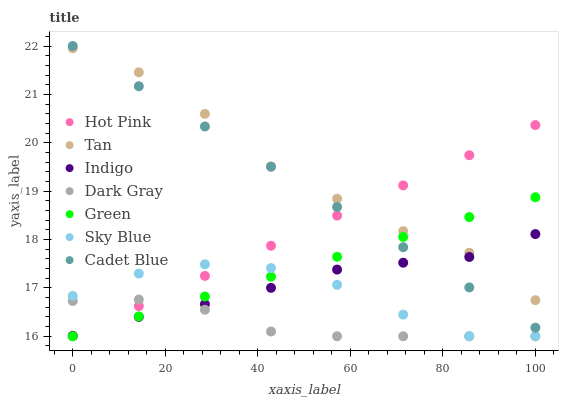Does Dark Gray have the minimum area under the curve?
Answer yes or no. Yes. Does Tan have the maximum area under the curve?
Answer yes or no. Yes. Does Indigo have the minimum area under the curve?
Answer yes or no. No. Does Indigo have the maximum area under the curve?
Answer yes or no. No. Is Green the smoothest?
Answer yes or no. Yes. Is Tan the roughest?
Answer yes or no. Yes. Is Indigo the smoothest?
Answer yes or no. No. Is Indigo the roughest?
Answer yes or no. No. Does Hot Pink have the lowest value?
Answer yes or no. Yes. Does Indigo have the lowest value?
Answer yes or no. No. Does Cadet Blue have the highest value?
Answer yes or no. Yes. Does Indigo have the highest value?
Answer yes or no. No. Is Sky Blue less than Cadet Blue?
Answer yes or no. Yes. Is Tan greater than Dark Gray?
Answer yes or no. Yes. Does Dark Gray intersect Indigo?
Answer yes or no. Yes. Is Dark Gray less than Indigo?
Answer yes or no. No. Is Dark Gray greater than Indigo?
Answer yes or no. No. Does Sky Blue intersect Cadet Blue?
Answer yes or no. No. 